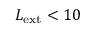<formula> <loc_0><loc_0><loc_500><loc_500>L _ { e x t } < 1 0</formula> 